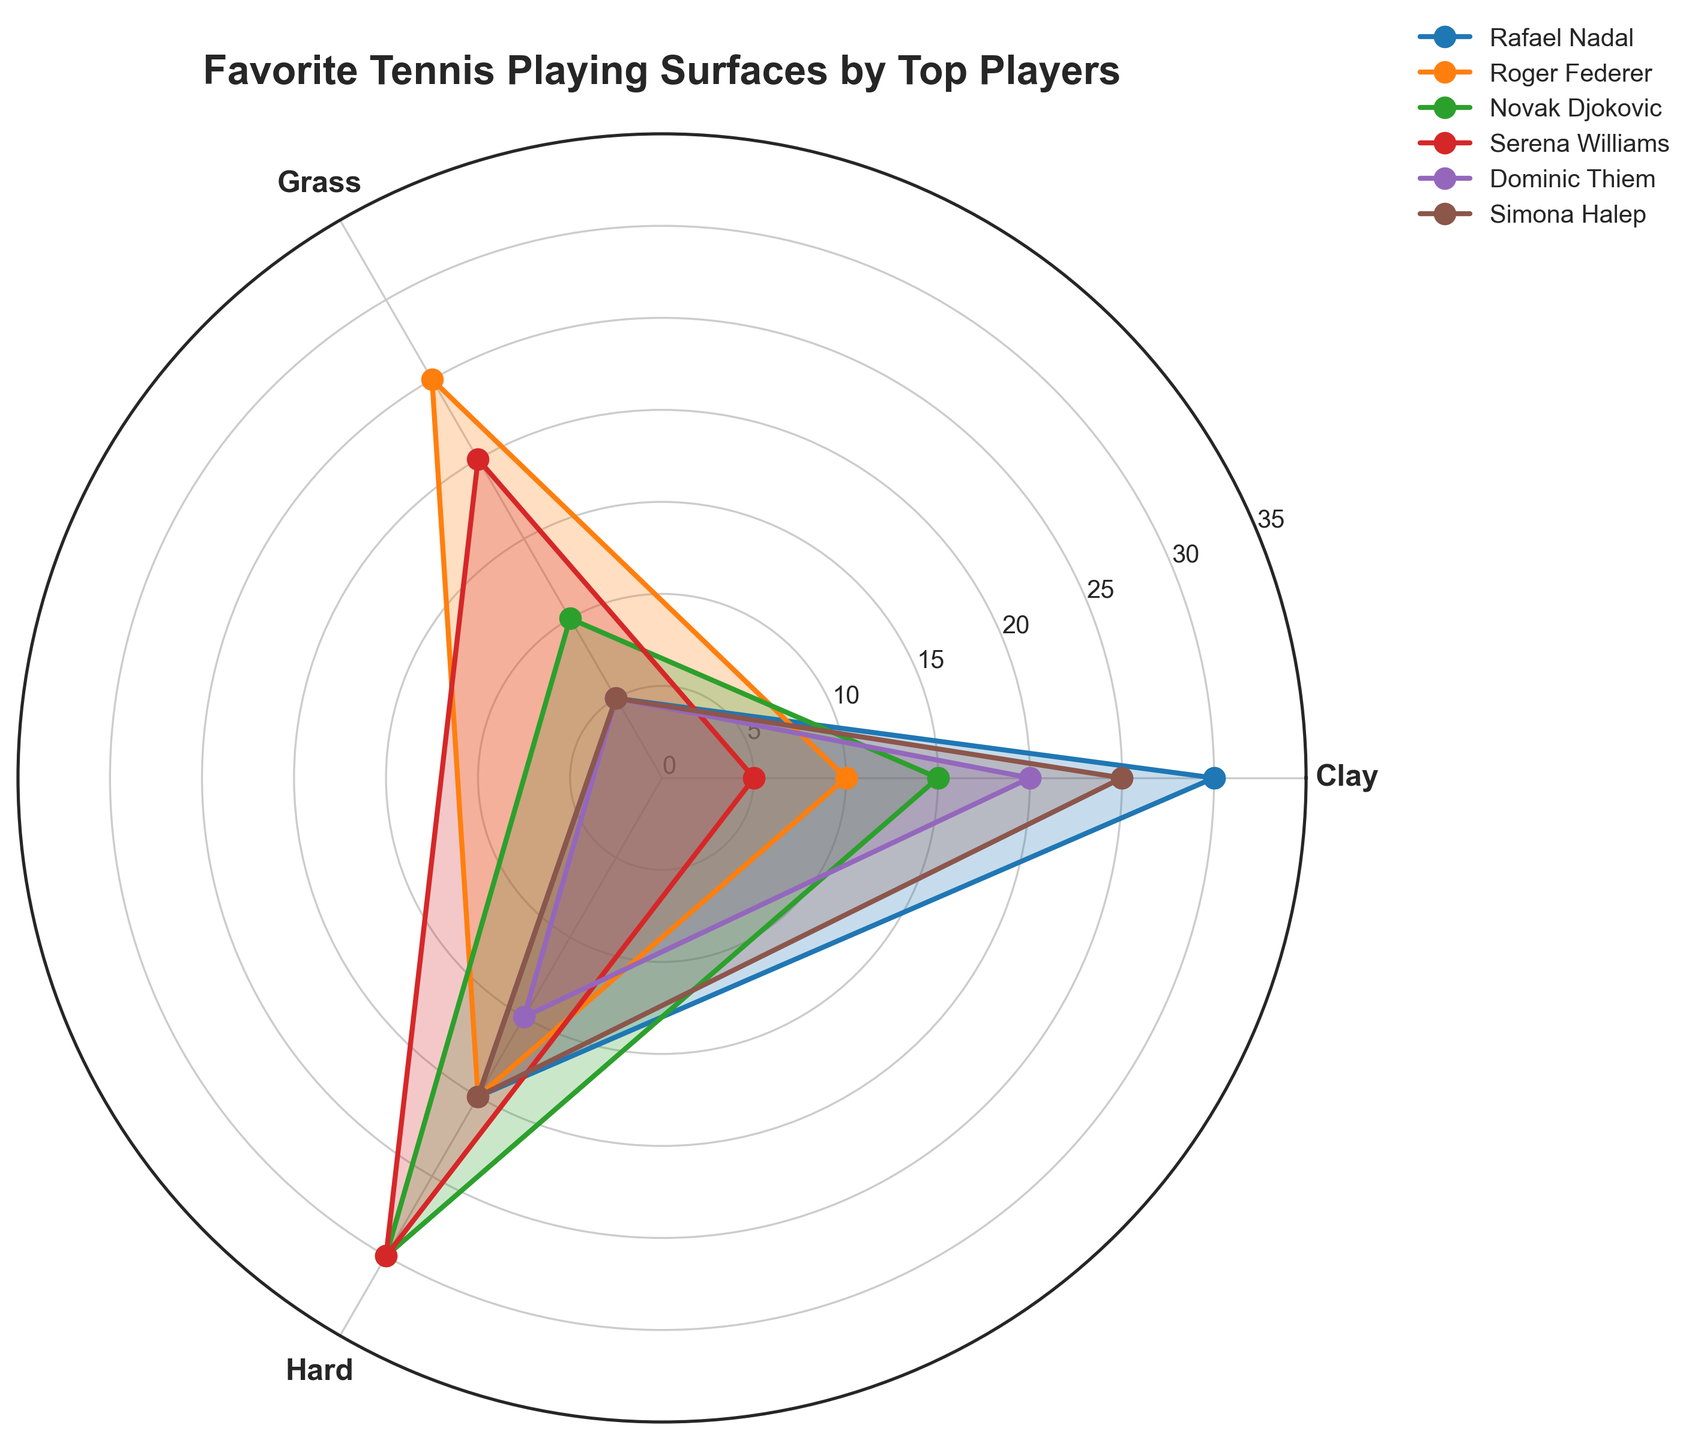What is the title of the figure? The title is typically found at the top of the figure, written in a larger font size to be easily noticeable. Here, it describes the primary focus of the rose chart.
Answer: "Favorite Tennis Playing Surfaces by Top Players" Which player prefers Grass the most? By looking at the 'Grass' section of the chart, identify which player's data extends the furthest out, indicating a higher preference.
Answer: Roger Federer How many players have a preference level above 20 for Hard surfaces? Observe the 'Hard' section and count the number of players with lines extending beyond the value of 20.
Answer: 3 Who has the highest preference for Clay courts? Locate the 'Clay' section and identify which player's data reaches the highest point.
Answer: Rafael Nadal What is the sum of preferences for Hard surfaces of Roger Federer and Serena Williams? For Roger Federer and Serena Williams, find their values for the 'Hard' surface and add them together: 20 (Federer) + 30 (Williams).
Answer: 50 Which player has the smallest variation in preferences between all surfaces? Calculate the range (difference between highest and lowest value) of preferences for each player. The player with the smallest range has the smallest variation. Analyze the lines for each player to determine this.
Answer: Simona Halep Compare the preferences of Rafael Nadal and Simona Halep for Clay and Grass surfaces. Who has a higher combined preference? Rafael Nadal has 30 (Clay) + 5 (Grass) = 35. Simona Halep has 25 (Clay) + 5 (Grass) = 30. Compare the sums.
Answer: Rafael Nadal Which surface is least preferred by the majority of players? Look at each player's data for the three surfaces and determine which surface has the most minimal values across players.
Answer: Grass What is the average preference for Clay courts across all players? Sum the preferences for Clay (30+10+15+5+20+25 = 105) and divide by the number of players (6). 105 / 6 = 17.5
Answer: 17.5 How does Novak Djokovic's preference for Hard surfaces compare to Serena Williams's? Find both players’ values for 'Hard' surfaces. Novak Djokovic has 30, while Serena Williams also has 30. Compare these values.
Answer: Equal 